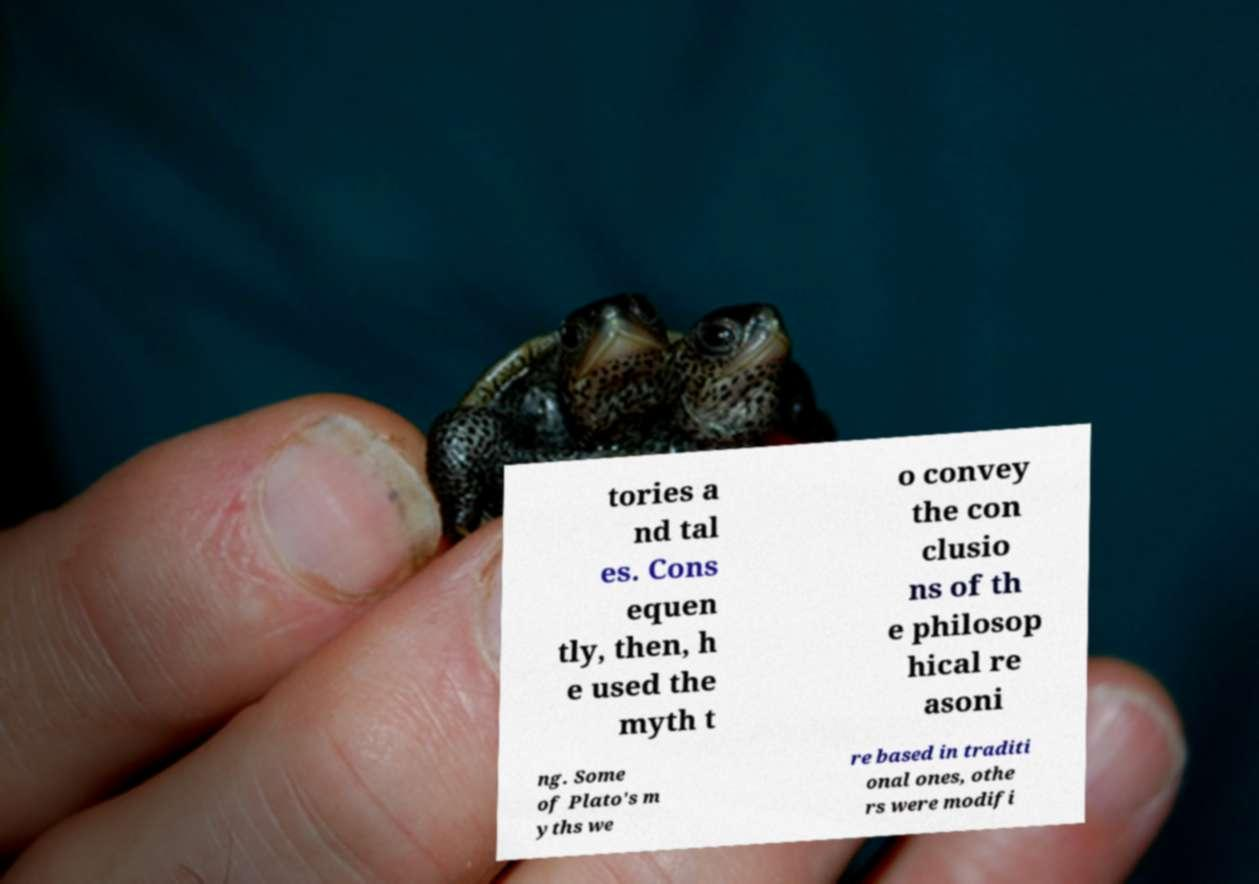What messages or text are displayed in this image? I need them in a readable, typed format. tories a nd tal es. Cons equen tly, then, h e used the myth t o convey the con clusio ns of th e philosop hical re asoni ng. Some of Plato's m yths we re based in traditi onal ones, othe rs were modifi 